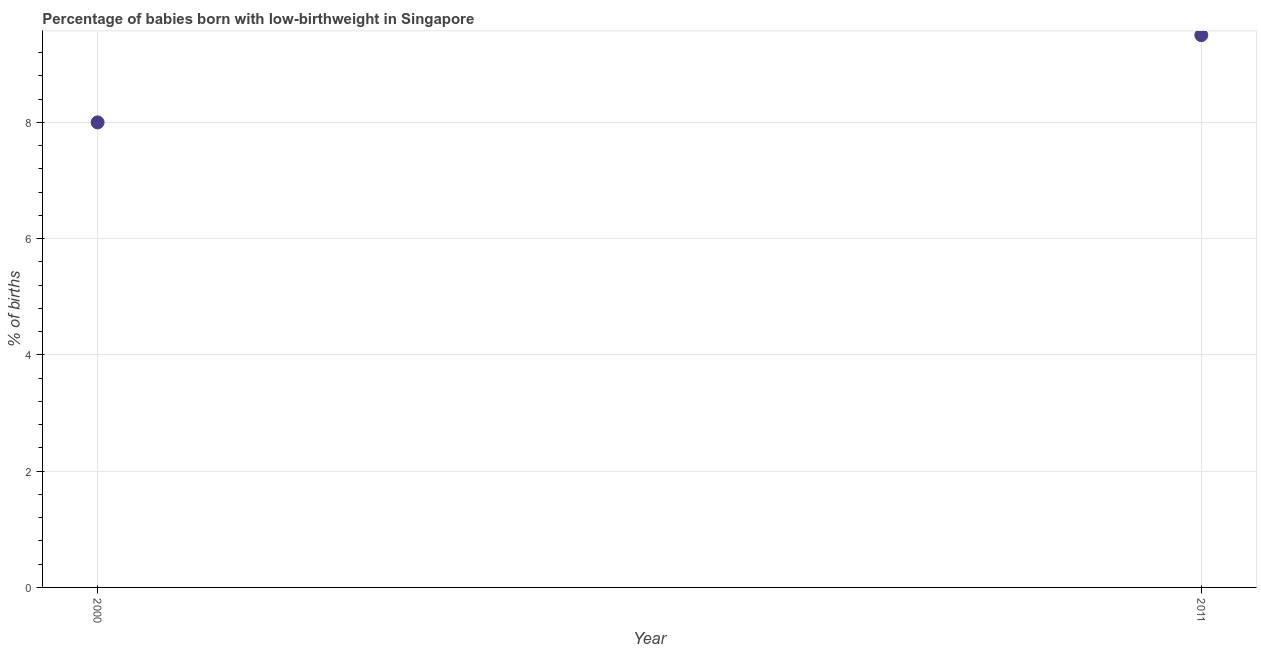What is the percentage of babies who were born with low-birthweight in 2011?
Provide a succinct answer. 9.5. In which year was the percentage of babies who were born with low-birthweight minimum?
Your answer should be very brief. 2000. What is the average percentage of babies who were born with low-birthweight per year?
Your response must be concise. 8.75. What is the median percentage of babies who were born with low-birthweight?
Keep it short and to the point. 8.75. What is the ratio of the percentage of babies who were born with low-birthweight in 2000 to that in 2011?
Your answer should be very brief. 0.84. Is the percentage of babies who were born with low-birthweight in 2000 less than that in 2011?
Give a very brief answer. Yes. How many dotlines are there?
Offer a very short reply. 1. Are the values on the major ticks of Y-axis written in scientific E-notation?
Your answer should be compact. No. Does the graph contain any zero values?
Offer a terse response. No. What is the title of the graph?
Your answer should be very brief. Percentage of babies born with low-birthweight in Singapore. What is the label or title of the Y-axis?
Provide a succinct answer. % of births. What is the % of births in 2011?
Offer a very short reply. 9.5. What is the difference between the % of births in 2000 and 2011?
Your response must be concise. -1.5. What is the ratio of the % of births in 2000 to that in 2011?
Offer a very short reply. 0.84. 